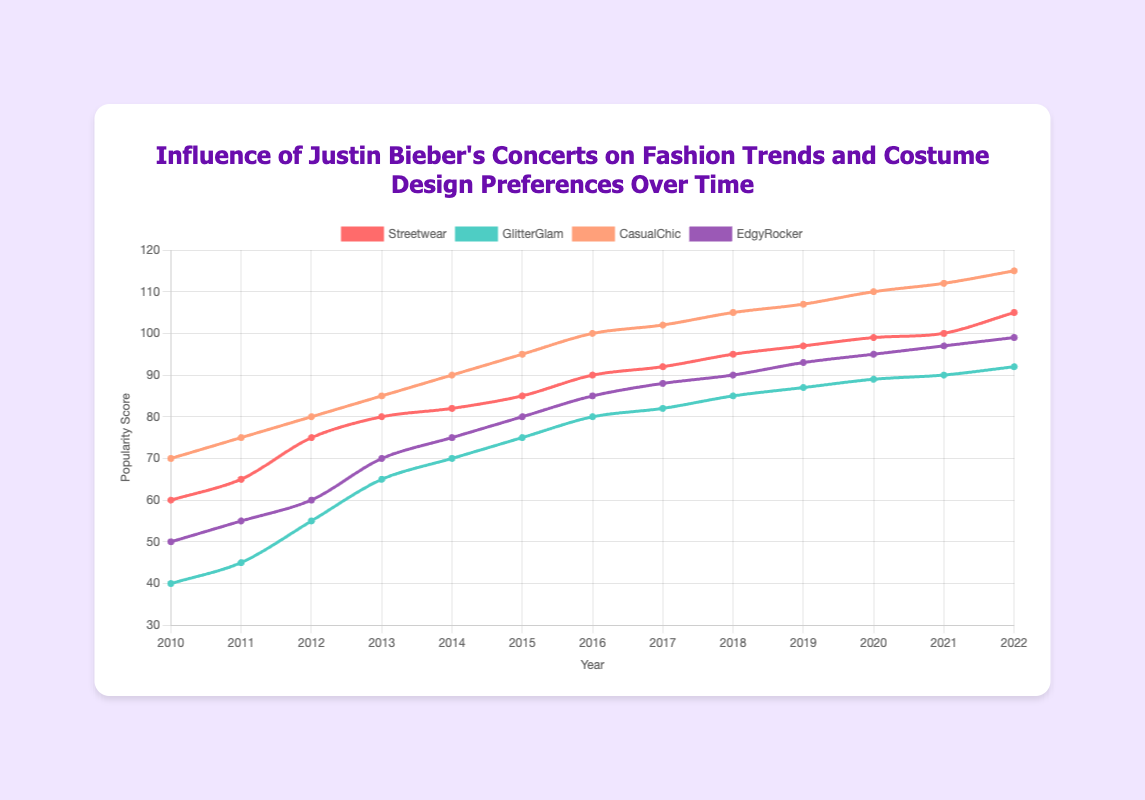Which fashion trend had the highest popularity score in 2013? To determine the highest popularity score in 2013, we compare the scores for each fashion trend: Streetwear (80), GlitterGlam (65), CasualChic (85), and EdgyRocker (70). The highest among these is 85 for CasualChic.
Answer: CasualChic How did the popularity of GlitterGlam change from 2010 to 2022? To observe the change, we look at the GlitterGlam scores in 2010 and 2022: 40 in 2010 and 92 in 2022. Subtracting the initial value from the final value gives 92 - 40 = 52, indicating an increase of 52 points.
Answer: Increased by 52 points What is the average popularity score for EdgyRocker from 2010 to 2022? First, sum the popularity scores for EdgyRocker from each year: 50 + 55 + 60 + 70 + 75 + 80 + 85 + 88 + 90 + 93 + 95 + 97 + 99 = 1037. Then, divide by the number of years (13), resulting in 1037 / 13 ≈ 79.77.
Answer: 79.77 Between Streetwear and CasualChic, which trend had a higher increase in popularity from 2010 to 2022? For Streetwear, the scores are 60 in 2010 and 105 in 2022, giving an increase of 105 - 60 = 45. For CasualChic, the scores are 70 in 2010 and 115 in 2022, giving an increase of 115 - 70 = 45. Both trends had the same increase in popularity.
Answer: Both the same In which year did EdgyRocker surpass 80 in popularity score for the first time? To find the first year EdgyRocker surpassed 80, we check the scores year by year until we find a score above 80. The first such score is 85 in 2015.
Answer: 2015 Based on the visual attributes, which fashion trend is represented by the red color? By observing the colors in the chart, the trend represented by the red color is identified. In this case, the line colored red corresponds to Streetwear.
Answer: Streetwear What is the combined popularity score of Streetwear and CasualChic in 2020? To find the combined score, add the popularity scores of Streetwear and CasualChic for 2020: 99 (Streetwear) + 110 (CasualChic) = 209.
Answer: 209 Which fashion trend showed the most consistent increase in popularity over the years? Evaluating each trend’s yearly scores, we see that CasualChic consistently increases each year.
Answer: CasualChic Compare the popularity scores of GlitterGlam and EdgyRocker in 2018 and state which is higher. For 2018, GlitterGlam's score is 85, and EdgyRocker's score is 90. Comparatively, EdgyRocker's score is higher by 5 points.
Answer: EdgyRocker by 5 points 